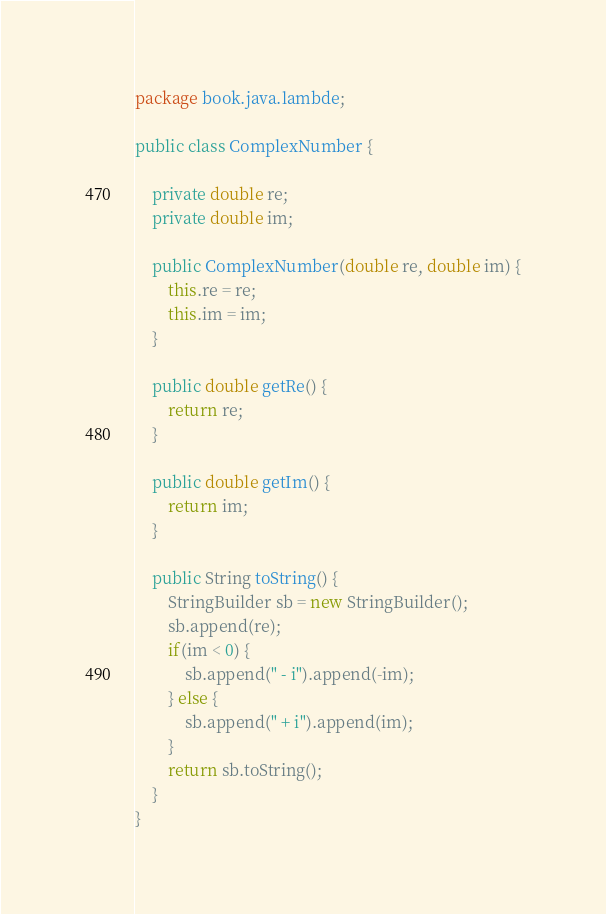<code> <loc_0><loc_0><loc_500><loc_500><_Java_>package book.java.lambde;

public class ComplexNumber {

    private double re;
    private double im;

    public ComplexNumber(double re, double im) {
        this.re = re;
        this.im = im;
    }

    public double getRe() {
        return re;
    }

    public double getIm() {
        return im;
    }

    public String toString() {
        StringBuilder sb = new StringBuilder();
        sb.append(re);
        if(im < 0) {
            sb.append(" - i").append(-im);
        } else {
            sb.append(" + i").append(im);
        }
        return sb.toString();
    }
}</code> 